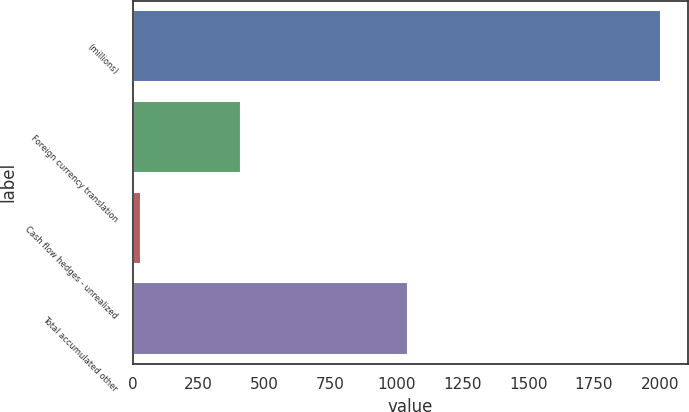Convert chart to OTSL. <chart><loc_0><loc_0><loc_500><loc_500><bar_chart><fcel>(millions)<fcel>Foreign currency translation<fcel>Cash flow hedges - unrealized<fcel>Total accumulated other<nl><fcel>2006<fcel>409.5<fcel>32.6<fcel>1046.2<nl></chart> 